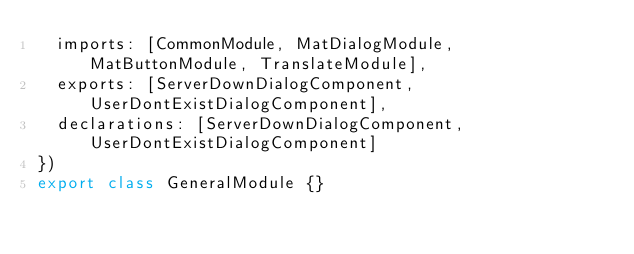<code> <loc_0><loc_0><loc_500><loc_500><_TypeScript_>  imports: [CommonModule, MatDialogModule, MatButtonModule, TranslateModule],
  exports: [ServerDownDialogComponent, UserDontExistDialogComponent],
  declarations: [ServerDownDialogComponent, UserDontExistDialogComponent]
})
export class GeneralModule {}
</code> 